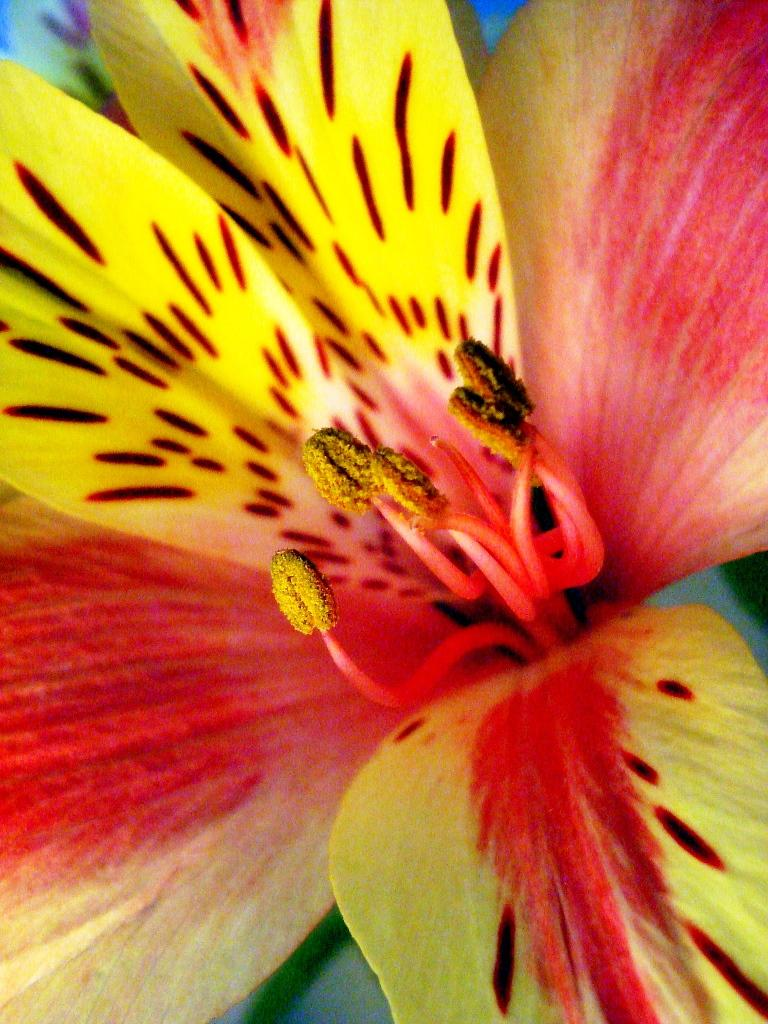What is the main subject of the image? The main subject of the image is a flower. Can you describe the flower in the image? The image is a zoomed-in picture of a flower, so it shows the flower's details closely. How many apples are hanging from the flower in the image? There are no apples present in the image, as it is a picture of a flower. Can you see a robin perched on the flower in the image? There is no robin present in the image; it is a close-up of a flower. 